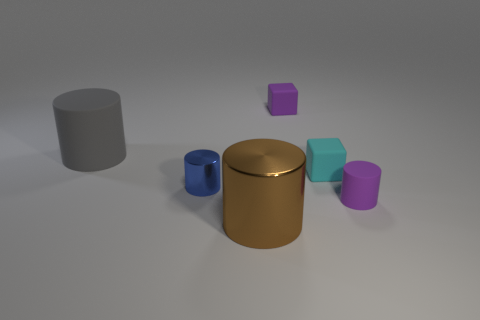What number of other objects are there of the same color as the small matte cylinder?
Keep it short and to the point. 1. There is a object that is the same size as the brown metal cylinder; what shape is it?
Give a very brief answer. Cylinder. What number of rubber blocks are in front of the tiny purple object behind the cylinder on the left side of the tiny blue metal cylinder?
Provide a short and direct response. 1. What number of shiny objects are small purple blocks or large cyan things?
Provide a succinct answer. 0. What color is the cylinder that is behind the brown cylinder and on the right side of the blue object?
Offer a very short reply. Purple. Is the size of the purple matte object behind the cyan rubber cube the same as the small purple rubber cylinder?
Ensure brevity in your answer.  Yes. How many things are either tiny objects that are behind the big gray rubber cylinder or tiny red matte spheres?
Your response must be concise. 1. Are there any cyan cubes of the same size as the blue metal cylinder?
Provide a short and direct response. Yes. What material is the gray object that is the same size as the brown object?
Your response must be concise. Rubber. There is a object that is both to the right of the large gray rubber object and left of the brown metallic object; what is its shape?
Offer a terse response. Cylinder. 